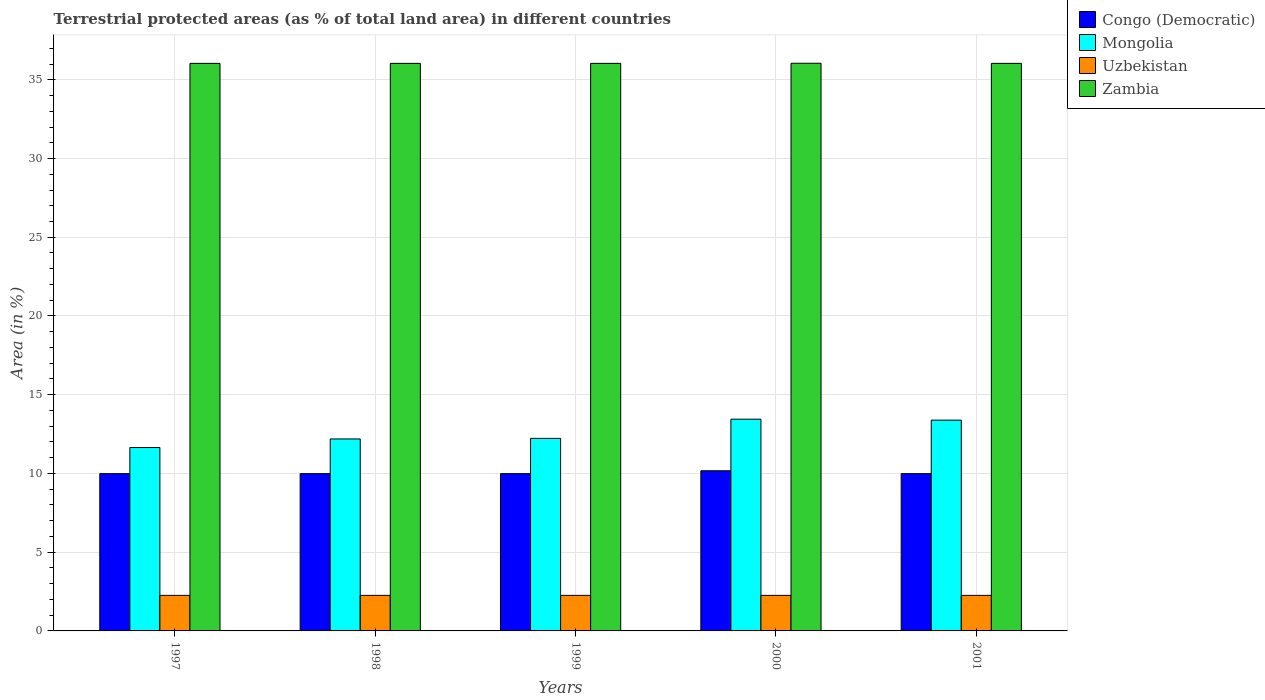How many different coloured bars are there?
Provide a succinct answer. 4. How many groups of bars are there?
Ensure brevity in your answer.  5. Are the number of bars per tick equal to the number of legend labels?
Offer a terse response. Yes. How many bars are there on the 5th tick from the left?
Your response must be concise. 4. What is the label of the 3rd group of bars from the left?
Offer a terse response. 1999. What is the percentage of terrestrial protected land in Congo (Democratic) in 2001?
Ensure brevity in your answer.  9.99. Across all years, what is the maximum percentage of terrestrial protected land in Zambia?
Give a very brief answer. 36.05. Across all years, what is the minimum percentage of terrestrial protected land in Zambia?
Your response must be concise. 36.04. What is the total percentage of terrestrial protected land in Zambia in the graph?
Give a very brief answer. 180.22. What is the difference between the percentage of terrestrial protected land in Mongolia in 1999 and that in 2000?
Offer a very short reply. -1.22. What is the difference between the percentage of terrestrial protected land in Mongolia in 2000 and the percentage of terrestrial protected land in Uzbekistan in 2001?
Keep it short and to the point. 11.19. What is the average percentage of terrestrial protected land in Congo (Democratic) per year?
Give a very brief answer. 10.02. In the year 1998, what is the difference between the percentage of terrestrial protected land in Uzbekistan and percentage of terrestrial protected land in Zambia?
Provide a succinct answer. -33.78. What is the ratio of the percentage of terrestrial protected land in Mongolia in 2000 to that in 2001?
Give a very brief answer. 1. Is the percentage of terrestrial protected land in Uzbekistan in 1997 less than that in 2000?
Ensure brevity in your answer.  Yes. What is the difference between the highest and the second highest percentage of terrestrial protected land in Mongolia?
Offer a terse response. 0.06. What is the difference between the highest and the lowest percentage of terrestrial protected land in Zambia?
Provide a short and direct response. 0.01. In how many years, is the percentage of terrestrial protected land in Uzbekistan greater than the average percentage of terrestrial protected land in Uzbekistan taken over all years?
Your answer should be very brief. 1. What does the 3rd bar from the left in 1997 represents?
Offer a terse response. Uzbekistan. What does the 3rd bar from the right in 1999 represents?
Provide a succinct answer. Mongolia. Is it the case that in every year, the sum of the percentage of terrestrial protected land in Congo (Democratic) and percentage of terrestrial protected land in Uzbekistan is greater than the percentage of terrestrial protected land in Zambia?
Offer a terse response. No. How many bars are there?
Give a very brief answer. 20. Are all the bars in the graph horizontal?
Make the answer very short. No. Does the graph contain any zero values?
Make the answer very short. No. Does the graph contain grids?
Give a very brief answer. Yes. What is the title of the graph?
Your answer should be very brief. Terrestrial protected areas (as % of total land area) in different countries. Does "Mauritania" appear as one of the legend labels in the graph?
Provide a succinct answer. No. What is the label or title of the X-axis?
Your response must be concise. Years. What is the label or title of the Y-axis?
Offer a terse response. Area (in %). What is the Area (in %) of Congo (Democratic) in 1997?
Keep it short and to the point. 9.99. What is the Area (in %) of Mongolia in 1997?
Ensure brevity in your answer.  11.65. What is the Area (in %) in Uzbekistan in 1997?
Offer a very short reply. 2.26. What is the Area (in %) in Zambia in 1997?
Offer a terse response. 36.04. What is the Area (in %) in Congo (Democratic) in 1998?
Give a very brief answer. 9.99. What is the Area (in %) in Mongolia in 1998?
Ensure brevity in your answer.  12.19. What is the Area (in %) of Uzbekistan in 1998?
Your answer should be very brief. 2.26. What is the Area (in %) of Zambia in 1998?
Give a very brief answer. 36.04. What is the Area (in %) of Congo (Democratic) in 1999?
Give a very brief answer. 9.99. What is the Area (in %) of Mongolia in 1999?
Offer a very short reply. 12.23. What is the Area (in %) in Uzbekistan in 1999?
Your answer should be compact. 2.26. What is the Area (in %) in Zambia in 1999?
Your answer should be very brief. 36.04. What is the Area (in %) in Congo (Democratic) in 2000?
Provide a succinct answer. 10.17. What is the Area (in %) in Mongolia in 2000?
Offer a very short reply. 13.45. What is the Area (in %) of Uzbekistan in 2000?
Give a very brief answer. 2.26. What is the Area (in %) of Zambia in 2000?
Give a very brief answer. 36.05. What is the Area (in %) in Congo (Democratic) in 2001?
Provide a short and direct response. 9.99. What is the Area (in %) in Mongolia in 2001?
Ensure brevity in your answer.  13.39. What is the Area (in %) in Uzbekistan in 2001?
Your response must be concise. 2.26. What is the Area (in %) in Zambia in 2001?
Make the answer very short. 36.04. Across all years, what is the maximum Area (in %) of Congo (Democratic)?
Ensure brevity in your answer.  10.17. Across all years, what is the maximum Area (in %) of Mongolia?
Keep it short and to the point. 13.45. Across all years, what is the maximum Area (in %) of Uzbekistan?
Make the answer very short. 2.26. Across all years, what is the maximum Area (in %) of Zambia?
Keep it short and to the point. 36.05. Across all years, what is the minimum Area (in %) of Congo (Democratic)?
Provide a succinct answer. 9.99. Across all years, what is the minimum Area (in %) in Mongolia?
Your answer should be very brief. 11.65. Across all years, what is the minimum Area (in %) of Uzbekistan?
Your answer should be compact. 2.26. Across all years, what is the minimum Area (in %) in Zambia?
Your response must be concise. 36.04. What is the total Area (in %) of Congo (Democratic) in the graph?
Offer a very short reply. 50.12. What is the total Area (in %) in Mongolia in the graph?
Keep it short and to the point. 62.9. What is the total Area (in %) in Uzbekistan in the graph?
Offer a very short reply. 11.29. What is the total Area (in %) in Zambia in the graph?
Your answer should be compact. 180.22. What is the difference between the Area (in %) in Mongolia in 1997 and that in 1998?
Offer a very short reply. -0.55. What is the difference between the Area (in %) of Zambia in 1997 and that in 1998?
Offer a very short reply. 0. What is the difference between the Area (in %) of Congo (Democratic) in 1997 and that in 1999?
Provide a short and direct response. 0. What is the difference between the Area (in %) of Mongolia in 1997 and that in 1999?
Provide a succinct answer. -0.58. What is the difference between the Area (in %) in Uzbekistan in 1997 and that in 1999?
Keep it short and to the point. 0. What is the difference between the Area (in %) of Congo (Democratic) in 1997 and that in 2000?
Offer a terse response. -0.18. What is the difference between the Area (in %) in Mongolia in 1997 and that in 2000?
Make the answer very short. -1.8. What is the difference between the Area (in %) in Zambia in 1997 and that in 2000?
Your response must be concise. -0.01. What is the difference between the Area (in %) in Mongolia in 1997 and that in 2001?
Offer a terse response. -1.74. What is the difference between the Area (in %) in Mongolia in 1998 and that in 1999?
Your answer should be very brief. -0.04. What is the difference between the Area (in %) in Congo (Democratic) in 1998 and that in 2000?
Provide a short and direct response. -0.18. What is the difference between the Area (in %) in Mongolia in 1998 and that in 2000?
Offer a terse response. -1.26. What is the difference between the Area (in %) of Uzbekistan in 1998 and that in 2000?
Ensure brevity in your answer.  -0. What is the difference between the Area (in %) in Zambia in 1998 and that in 2000?
Offer a terse response. -0.01. What is the difference between the Area (in %) of Mongolia in 1998 and that in 2001?
Keep it short and to the point. -1.2. What is the difference between the Area (in %) of Uzbekistan in 1998 and that in 2001?
Offer a terse response. 0. What is the difference between the Area (in %) in Congo (Democratic) in 1999 and that in 2000?
Your answer should be compact. -0.18. What is the difference between the Area (in %) of Mongolia in 1999 and that in 2000?
Provide a succinct answer. -1.22. What is the difference between the Area (in %) in Uzbekistan in 1999 and that in 2000?
Your response must be concise. -0. What is the difference between the Area (in %) in Zambia in 1999 and that in 2000?
Your response must be concise. -0.01. What is the difference between the Area (in %) in Mongolia in 1999 and that in 2001?
Ensure brevity in your answer.  -1.16. What is the difference between the Area (in %) of Congo (Democratic) in 2000 and that in 2001?
Provide a succinct answer. 0.18. What is the difference between the Area (in %) of Mongolia in 2000 and that in 2001?
Keep it short and to the point. 0.06. What is the difference between the Area (in %) of Zambia in 2000 and that in 2001?
Offer a very short reply. 0.01. What is the difference between the Area (in %) of Congo (Democratic) in 1997 and the Area (in %) of Mongolia in 1998?
Your answer should be very brief. -2.2. What is the difference between the Area (in %) of Congo (Democratic) in 1997 and the Area (in %) of Uzbekistan in 1998?
Give a very brief answer. 7.73. What is the difference between the Area (in %) in Congo (Democratic) in 1997 and the Area (in %) in Zambia in 1998?
Provide a short and direct response. -26.06. What is the difference between the Area (in %) in Mongolia in 1997 and the Area (in %) in Uzbekistan in 1998?
Provide a succinct answer. 9.39. What is the difference between the Area (in %) in Mongolia in 1997 and the Area (in %) in Zambia in 1998?
Offer a very short reply. -24.4. What is the difference between the Area (in %) of Uzbekistan in 1997 and the Area (in %) of Zambia in 1998?
Your response must be concise. -33.78. What is the difference between the Area (in %) of Congo (Democratic) in 1997 and the Area (in %) of Mongolia in 1999?
Make the answer very short. -2.24. What is the difference between the Area (in %) in Congo (Democratic) in 1997 and the Area (in %) in Uzbekistan in 1999?
Offer a terse response. 7.73. What is the difference between the Area (in %) in Congo (Democratic) in 1997 and the Area (in %) in Zambia in 1999?
Your answer should be compact. -26.06. What is the difference between the Area (in %) of Mongolia in 1997 and the Area (in %) of Uzbekistan in 1999?
Give a very brief answer. 9.39. What is the difference between the Area (in %) in Mongolia in 1997 and the Area (in %) in Zambia in 1999?
Your answer should be very brief. -24.4. What is the difference between the Area (in %) in Uzbekistan in 1997 and the Area (in %) in Zambia in 1999?
Provide a short and direct response. -33.78. What is the difference between the Area (in %) of Congo (Democratic) in 1997 and the Area (in %) of Mongolia in 2000?
Keep it short and to the point. -3.46. What is the difference between the Area (in %) of Congo (Democratic) in 1997 and the Area (in %) of Uzbekistan in 2000?
Your answer should be very brief. 7.73. What is the difference between the Area (in %) in Congo (Democratic) in 1997 and the Area (in %) in Zambia in 2000?
Keep it short and to the point. -26.06. What is the difference between the Area (in %) of Mongolia in 1997 and the Area (in %) of Uzbekistan in 2000?
Provide a short and direct response. 9.39. What is the difference between the Area (in %) of Mongolia in 1997 and the Area (in %) of Zambia in 2000?
Provide a succinct answer. -24.4. What is the difference between the Area (in %) in Uzbekistan in 1997 and the Area (in %) in Zambia in 2000?
Offer a terse response. -33.79. What is the difference between the Area (in %) of Congo (Democratic) in 1997 and the Area (in %) of Mongolia in 2001?
Provide a short and direct response. -3.4. What is the difference between the Area (in %) of Congo (Democratic) in 1997 and the Area (in %) of Uzbekistan in 2001?
Your answer should be very brief. 7.73. What is the difference between the Area (in %) of Congo (Democratic) in 1997 and the Area (in %) of Zambia in 2001?
Your response must be concise. -26.06. What is the difference between the Area (in %) of Mongolia in 1997 and the Area (in %) of Uzbekistan in 2001?
Offer a very short reply. 9.39. What is the difference between the Area (in %) of Mongolia in 1997 and the Area (in %) of Zambia in 2001?
Make the answer very short. -24.4. What is the difference between the Area (in %) of Uzbekistan in 1997 and the Area (in %) of Zambia in 2001?
Make the answer very short. -33.78. What is the difference between the Area (in %) of Congo (Democratic) in 1998 and the Area (in %) of Mongolia in 1999?
Provide a short and direct response. -2.24. What is the difference between the Area (in %) in Congo (Democratic) in 1998 and the Area (in %) in Uzbekistan in 1999?
Offer a very short reply. 7.73. What is the difference between the Area (in %) in Congo (Democratic) in 1998 and the Area (in %) in Zambia in 1999?
Ensure brevity in your answer.  -26.06. What is the difference between the Area (in %) in Mongolia in 1998 and the Area (in %) in Uzbekistan in 1999?
Your answer should be compact. 9.93. What is the difference between the Area (in %) of Mongolia in 1998 and the Area (in %) of Zambia in 1999?
Make the answer very short. -23.85. What is the difference between the Area (in %) in Uzbekistan in 1998 and the Area (in %) in Zambia in 1999?
Provide a short and direct response. -33.78. What is the difference between the Area (in %) of Congo (Democratic) in 1998 and the Area (in %) of Mongolia in 2000?
Keep it short and to the point. -3.46. What is the difference between the Area (in %) in Congo (Democratic) in 1998 and the Area (in %) in Uzbekistan in 2000?
Your answer should be compact. 7.73. What is the difference between the Area (in %) in Congo (Democratic) in 1998 and the Area (in %) in Zambia in 2000?
Give a very brief answer. -26.06. What is the difference between the Area (in %) in Mongolia in 1998 and the Area (in %) in Uzbekistan in 2000?
Provide a short and direct response. 9.93. What is the difference between the Area (in %) in Mongolia in 1998 and the Area (in %) in Zambia in 2000?
Provide a short and direct response. -23.86. What is the difference between the Area (in %) in Uzbekistan in 1998 and the Area (in %) in Zambia in 2000?
Offer a very short reply. -33.79. What is the difference between the Area (in %) of Congo (Democratic) in 1998 and the Area (in %) of Mongolia in 2001?
Offer a terse response. -3.4. What is the difference between the Area (in %) of Congo (Democratic) in 1998 and the Area (in %) of Uzbekistan in 2001?
Offer a terse response. 7.73. What is the difference between the Area (in %) of Congo (Democratic) in 1998 and the Area (in %) of Zambia in 2001?
Your response must be concise. -26.06. What is the difference between the Area (in %) in Mongolia in 1998 and the Area (in %) in Uzbekistan in 2001?
Offer a very short reply. 9.93. What is the difference between the Area (in %) of Mongolia in 1998 and the Area (in %) of Zambia in 2001?
Your answer should be very brief. -23.85. What is the difference between the Area (in %) of Uzbekistan in 1998 and the Area (in %) of Zambia in 2001?
Ensure brevity in your answer.  -33.78. What is the difference between the Area (in %) in Congo (Democratic) in 1999 and the Area (in %) in Mongolia in 2000?
Keep it short and to the point. -3.46. What is the difference between the Area (in %) in Congo (Democratic) in 1999 and the Area (in %) in Uzbekistan in 2000?
Your answer should be compact. 7.73. What is the difference between the Area (in %) of Congo (Democratic) in 1999 and the Area (in %) of Zambia in 2000?
Your answer should be very brief. -26.06. What is the difference between the Area (in %) of Mongolia in 1999 and the Area (in %) of Uzbekistan in 2000?
Offer a terse response. 9.97. What is the difference between the Area (in %) of Mongolia in 1999 and the Area (in %) of Zambia in 2000?
Offer a terse response. -23.82. What is the difference between the Area (in %) of Uzbekistan in 1999 and the Area (in %) of Zambia in 2000?
Give a very brief answer. -33.79. What is the difference between the Area (in %) in Congo (Democratic) in 1999 and the Area (in %) in Mongolia in 2001?
Offer a very short reply. -3.4. What is the difference between the Area (in %) of Congo (Democratic) in 1999 and the Area (in %) of Uzbekistan in 2001?
Ensure brevity in your answer.  7.73. What is the difference between the Area (in %) of Congo (Democratic) in 1999 and the Area (in %) of Zambia in 2001?
Offer a very short reply. -26.06. What is the difference between the Area (in %) of Mongolia in 1999 and the Area (in %) of Uzbekistan in 2001?
Provide a short and direct response. 9.97. What is the difference between the Area (in %) of Mongolia in 1999 and the Area (in %) of Zambia in 2001?
Give a very brief answer. -23.81. What is the difference between the Area (in %) of Uzbekistan in 1999 and the Area (in %) of Zambia in 2001?
Your answer should be very brief. -33.78. What is the difference between the Area (in %) in Congo (Democratic) in 2000 and the Area (in %) in Mongolia in 2001?
Provide a short and direct response. -3.22. What is the difference between the Area (in %) in Congo (Democratic) in 2000 and the Area (in %) in Uzbekistan in 2001?
Your answer should be very brief. 7.91. What is the difference between the Area (in %) in Congo (Democratic) in 2000 and the Area (in %) in Zambia in 2001?
Your answer should be compact. -25.87. What is the difference between the Area (in %) in Mongolia in 2000 and the Area (in %) in Uzbekistan in 2001?
Your answer should be very brief. 11.19. What is the difference between the Area (in %) of Mongolia in 2000 and the Area (in %) of Zambia in 2001?
Offer a terse response. -22.6. What is the difference between the Area (in %) in Uzbekistan in 2000 and the Area (in %) in Zambia in 2001?
Offer a terse response. -33.78. What is the average Area (in %) of Congo (Democratic) per year?
Your response must be concise. 10.02. What is the average Area (in %) of Mongolia per year?
Provide a short and direct response. 12.58. What is the average Area (in %) of Uzbekistan per year?
Give a very brief answer. 2.26. What is the average Area (in %) of Zambia per year?
Provide a succinct answer. 36.04. In the year 1997, what is the difference between the Area (in %) of Congo (Democratic) and Area (in %) of Mongolia?
Ensure brevity in your answer.  -1.66. In the year 1997, what is the difference between the Area (in %) in Congo (Democratic) and Area (in %) in Uzbekistan?
Make the answer very short. 7.73. In the year 1997, what is the difference between the Area (in %) in Congo (Democratic) and Area (in %) in Zambia?
Your answer should be very brief. -26.06. In the year 1997, what is the difference between the Area (in %) in Mongolia and Area (in %) in Uzbekistan?
Make the answer very short. 9.39. In the year 1997, what is the difference between the Area (in %) of Mongolia and Area (in %) of Zambia?
Offer a very short reply. -24.4. In the year 1997, what is the difference between the Area (in %) in Uzbekistan and Area (in %) in Zambia?
Provide a short and direct response. -33.78. In the year 1998, what is the difference between the Area (in %) in Congo (Democratic) and Area (in %) in Mongolia?
Your response must be concise. -2.2. In the year 1998, what is the difference between the Area (in %) of Congo (Democratic) and Area (in %) of Uzbekistan?
Offer a very short reply. 7.73. In the year 1998, what is the difference between the Area (in %) in Congo (Democratic) and Area (in %) in Zambia?
Your response must be concise. -26.06. In the year 1998, what is the difference between the Area (in %) of Mongolia and Area (in %) of Uzbekistan?
Ensure brevity in your answer.  9.93. In the year 1998, what is the difference between the Area (in %) in Mongolia and Area (in %) in Zambia?
Keep it short and to the point. -23.85. In the year 1998, what is the difference between the Area (in %) in Uzbekistan and Area (in %) in Zambia?
Your answer should be compact. -33.78. In the year 1999, what is the difference between the Area (in %) of Congo (Democratic) and Area (in %) of Mongolia?
Make the answer very short. -2.24. In the year 1999, what is the difference between the Area (in %) in Congo (Democratic) and Area (in %) in Uzbekistan?
Give a very brief answer. 7.73. In the year 1999, what is the difference between the Area (in %) of Congo (Democratic) and Area (in %) of Zambia?
Your answer should be very brief. -26.06. In the year 1999, what is the difference between the Area (in %) in Mongolia and Area (in %) in Uzbekistan?
Make the answer very short. 9.97. In the year 1999, what is the difference between the Area (in %) of Mongolia and Area (in %) of Zambia?
Provide a succinct answer. -23.81. In the year 1999, what is the difference between the Area (in %) in Uzbekistan and Area (in %) in Zambia?
Make the answer very short. -33.78. In the year 2000, what is the difference between the Area (in %) of Congo (Democratic) and Area (in %) of Mongolia?
Give a very brief answer. -3.28. In the year 2000, what is the difference between the Area (in %) in Congo (Democratic) and Area (in %) in Uzbekistan?
Your response must be concise. 7.91. In the year 2000, what is the difference between the Area (in %) of Congo (Democratic) and Area (in %) of Zambia?
Make the answer very short. -25.88. In the year 2000, what is the difference between the Area (in %) in Mongolia and Area (in %) in Uzbekistan?
Offer a terse response. 11.19. In the year 2000, what is the difference between the Area (in %) in Mongolia and Area (in %) in Zambia?
Offer a terse response. -22.6. In the year 2000, what is the difference between the Area (in %) in Uzbekistan and Area (in %) in Zambia?
Offer a very short reply. -33.79. In the year 2001, what is the difference between the Area (in %) in Congo (Democratic) and Area (in %) in Mongolia?
Your answer should be very brief. -3.4. In the year 2001, what is the difference between the Area (in %) of Congo (Democratic) and Area (in %) of Uzbekistan?
Provide a succinct answer. 7.73. In the year 2001, what is the difference between the Area (in %) of Congo (Democratic) and Area (in %) of Zambia?
Provide a short and direct response. -26.06. In the year 2001, what is the difference between the Area (in %) in Mongolia and Area (in %) in Uzbekistan?
Keep it short and to the point. 11.13. In the year 2001, what is the difference between the Area (in %) in Mongolia and Area (in %) in Zambia?
Offer a very short reply. -22.66. In the year 2001, what is the difference between the Area (in %) in Uzbekistan and Area (in %) in Zambia?
Make the answer very short. -33.78. What is the ratio of the Area (in %) in Congo (Democratic) in 1997 to that in 1998?
Give a very brief answer. 1. What is the ratio of the Area (in %) of Mongolia in 1997 to that in 1998?
Keep it short and to the point. 0.96. What is the ratio of the Area (in %) in Zambia in 1997 to that in 1998?
Offer a terse response. 1. What is the ratio of the Area (in %) in Uzbekistan in 1997 to that in 1999?
Your response must be concise. 1. What is the ratio of the Area (in %) in Zambia in 1997 to that in 1999?
Provide a succinct answer. 1. What is the ratio of the Area (in %) in Congo (Democratic) in 1997 to that in 2000?
Ensure brevity in your answer.  0.98. What is the ratio of the Area (in %) in Mongolia in 1997 to that in 2000?
Offer a terse response. 0.87. What is the ratio of the Area (in %) in Mongolia in 1997 to that in 2001?
Provide a succinct answer. 0.87. What is the ratio of the Area (in %) of Uzbekistan in 1997 to that in 2001?
Give a very brief answer. 1. What is the ratio of the Area (in %) in Congo (Democratic) in 1998 to that in 1999?
Offer a terse response. 1. What is the ratio of the Area (in %) of Mongolia in 1998 to that in 1999?
Your answer should be very brief. 1. What is the ratio of the Area (in %) of Congo (Democratic) in 1998 to that in 2000?
Offer a very short reply. 0.98. What is the ratio of the Area (in %) of Mongolia in 1998 to that in 2000?
Your answer should be very brief. 0.91. What is the ratio of the Area (in %) in Uzbekistan in 1998 to that in 2000?
Keep it short and to the point. 1. What is the ratio of the Area (in %) in Zambia in 1998 to that in 2000?
Your answer should be very brief. 1. What is the ratio of the Area (in %) in Congo (Democratic) in 1998 to that in 2001?
Your response must be concise. 1. What is the ratio of the Area (in %) of Mongolia in 1998 to that in 2001?
Give a very brief answer. 0.91. What is the ratio of the Area (in %) in Congo (Democratic) in 1999 to that in 2000?
Offer a very short reply. 0.98. What is the ratio of the Area (in %) of Mongolia in 1999 to that in 2000?
Keep it short and to the point. 0.91. What is the ratio of the Area (in %) in Uzbekistan in 1999 to that in 2000?
Offer a very short reply. 1. What is the ratio of the Area (in %) of Zambia in 1999 to that in 2000?
Make the answer very short. 1. What is the ratio of the Area (in %) of Mongolia in 1999 to that in 2001?
Provide a short and direct response. 0.91. What is the ratio of the Area (in %) in Uzbekistan in 1999 to that in 2001?
Your answer should be compact. 1. What is the ratio of the Area (in %) of Zambia in 1999 to that in 2001?
Your answer should be very brief. 1. What is the ratio of the Area (in %) of Congo (Democratic) in 2000 to that in 2001?
Offer a terse response. 1.02. What is the ratio of the Area (in %) of Uzbekistan in 2000 to that in 2001?
Provide a short and direct response. 1. What is the ratio of the Area (in %) in Zambia in 2000 to that in 2001?
Offer a very short reply. 1. What is the difference between the highest and the second highest Area (in %) in Congo (Democratic)?
Provide a short and direct response. 0.18. What is the difference between the highest and the second highest Area (in %) of Mongolia?
Your response must be concise. 0.06. What is the difference between the highest and the second highest Area (in %) in Zambia?
Offer a very short reply. 0.01. What is the difference between the highest and the lowest Area (in %) in Congo (Democratic)?
Your answer should be very brief. 0.18. What is the difference between the highest and the lowest Area (in %) in Mongolia?
Your answer should be compact. 1.8. What is the difference between the highest and the lowest Area (in %) in Zambia?
Provide a succinct answer. 0.01. 